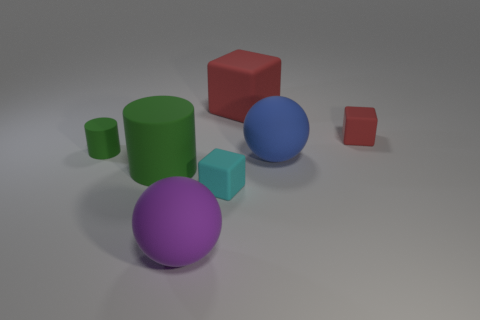Is there a large object made of the same material as the cyan cube?
Offer a very short reply. Yes. What is the size of the matte thing that is the same color as the large rubber cylinder?
Offer a very short reply. Small. What is the color of the tiny matte object to the left of the matte ball in front of the cyan rubber block?
Your answer should be very brief. Green. Is the purple matte ball the same size as the blue matte thing?
Make the answer very short. Yes. How many cylinders are either green things or big yellow metallic things?
Your answer should be very brief. 2. What number of large rubber cylinders are on the right side of the large purple ball that is to the right of the tiny matte cylinder?
Your response must be concise. 0. Is the large green object the same shape as the tiny cyan rubber object?
Your response must be concise. No. There is a blue rubber object that is the same shape as the large purple matte object; what size is it?
Offer a very short reply. Large. What is the shape of the small matte object that is in front of the green matte cylinder that is to the left of the big green rubber thing?
Your response must be concise. Cube. What is the size of the cyan thing?
Provide a succinct answer. Small. 